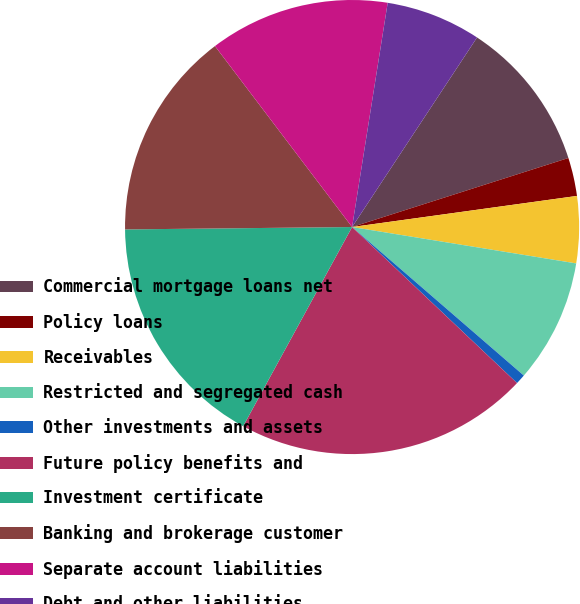Convert chart. <chart><loc_0><loc_0><loc_500><loc_500><pie_chart><fcel>Commercial mortgage loans net<fcel>Policy loans<fcel>Receivables<fcel>Restricted and segregated cash<fcel>Other investments and assets<fcel>Future policy benefits and<fcel>Investment certificate<fcel>Banking and brokerage customer<fcel>Separate account liabilities<fcel>Debt and other liabilities<nl><fcel>10.81%<fcel>2.73%<fcel>4.75%<fcel>8.79%<fcel>0.71%<fcel>20.91%<fcel>16.87%<fcel>14.85%<fcel>12.83%<fcel>6.77%<nl></chart> 